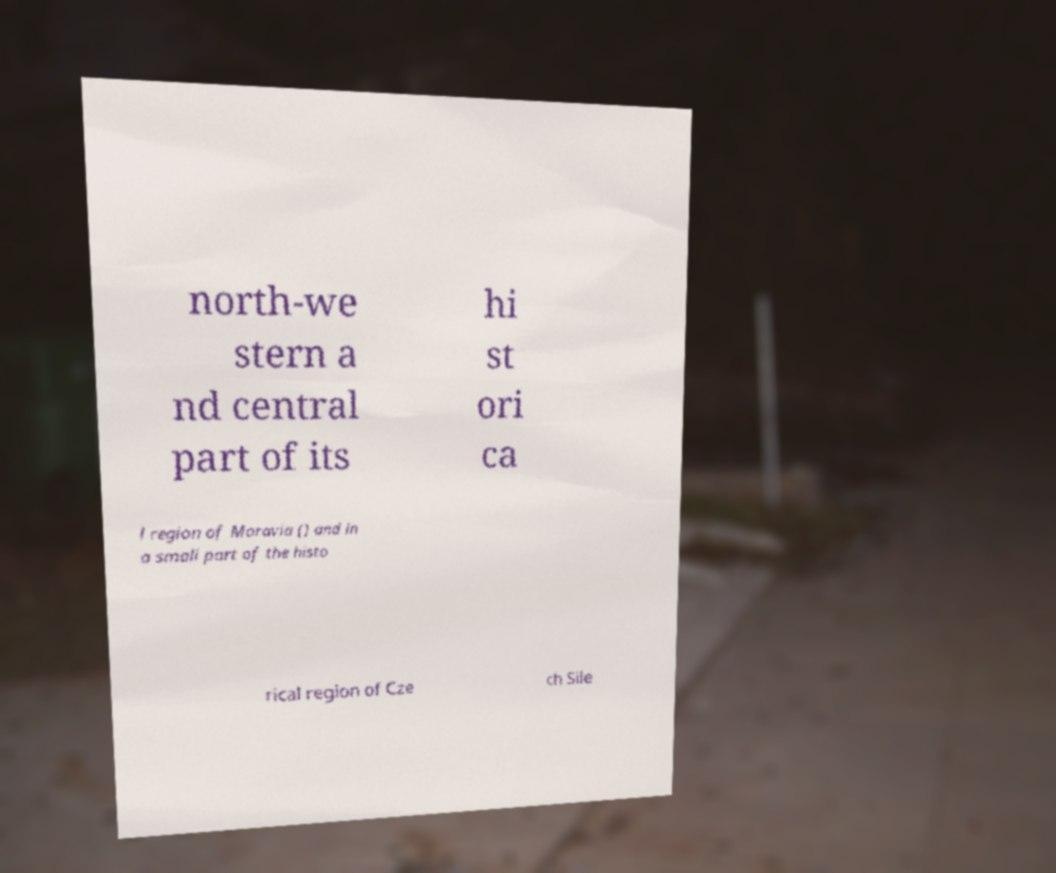Can you accurately transcribe the text from the provided image for me? north-we stern a nd central part of its hi st ori ca l region of Moravia () and in a small part of the histo rical region of Cze ch Sile 